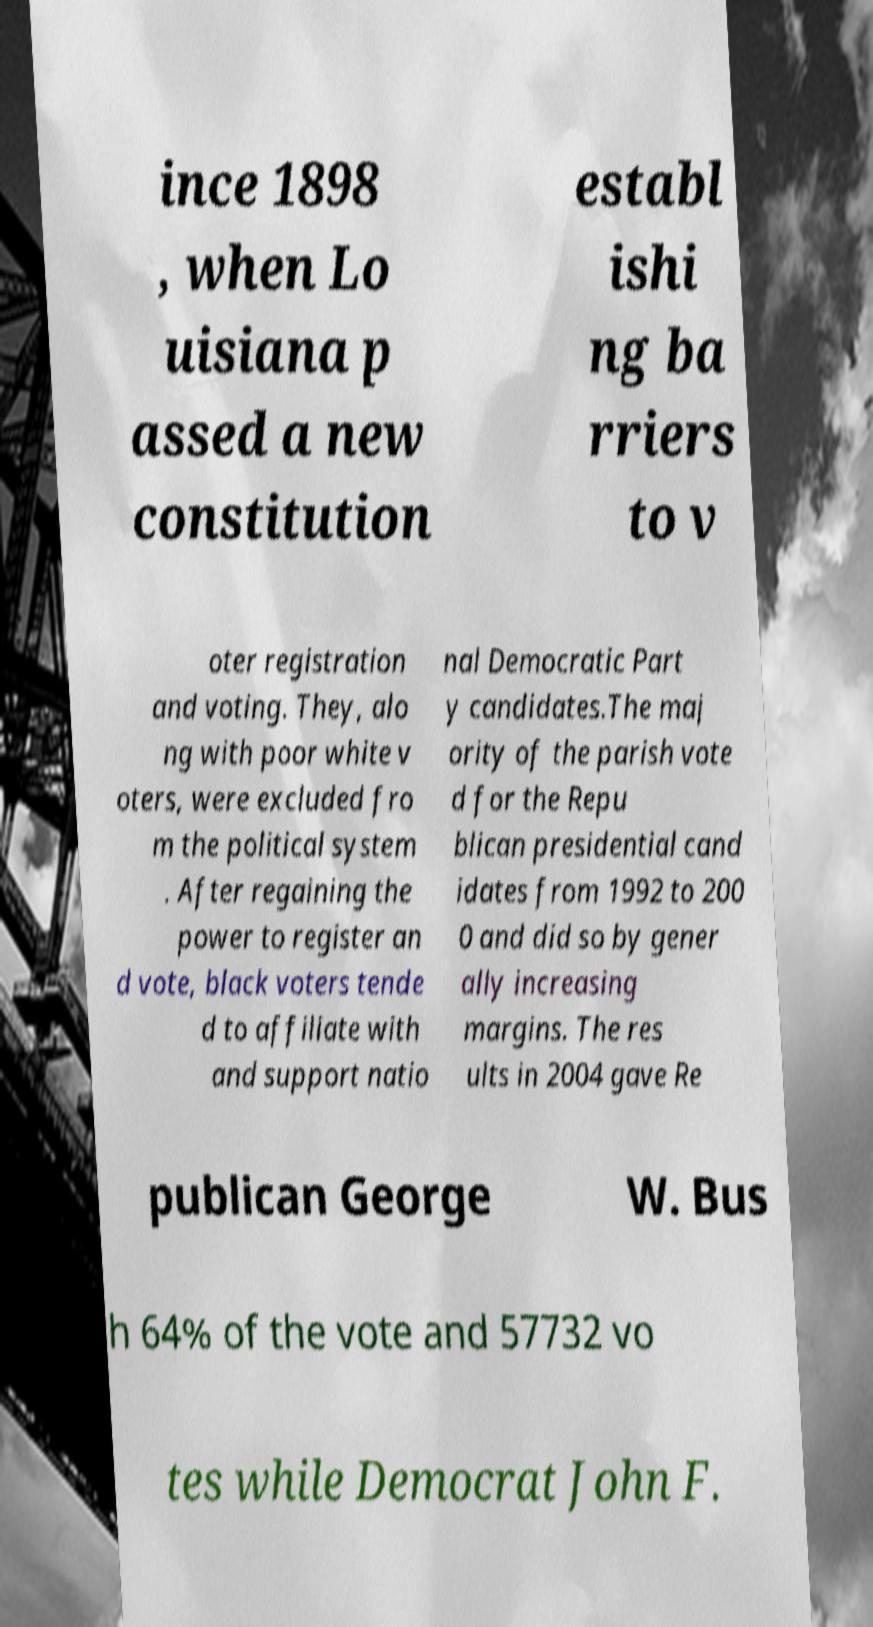Please identify and transcribe the text found in this image. ince 1898 , when Lo uisiana p assed a new constitution establ ishi ng ba rriers to v oter registration and voting. They, alo ng with poor white v oters, were excluded fro m the political system . After regaining the power to register an d vote, black voters tende d to affiliate with and support natio nal Democratic Part y candidates.The maj ority of the parish vote d for the Repu blican presidential cand idates from 1992 to 200 0 and did so by gener ally increasing margins. The res ults in 2004 gave Re publican George W. Bus h 64% of the vote and 57732 vo tes while Democrat John F. 